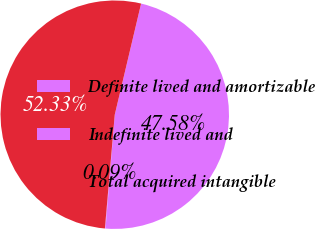Convert chart to OTSL. <chart><loc_0><loc_0><loc_500><loc_500><pie_chart><fcel>Definite lived and amortizable<fcel>Indefinite lived and<fcel>Total acquired intangible<nl><fcel>47.58%<fcel>0.09%<fcel>52.33%<nl></chart> 